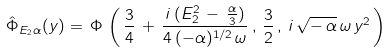Convert formula to latex. <formula><loc_0><loc_0><loc_500><loc_500>\hat { \Phi } _ { E _ { 2 } \alpha } ( y ) = \, \Phi \, \left ( \, \frac { 3 } { 4 } \, + \, \frac { i \, ( E _ { 2 } ^ { 2 } \, - \, \frac { \alpha } { 3 } ) } { 4 \, ( - \alpha ) ^ { 1 / 2 } \, \omega } \, , \, \frac { 3 } { 2 } \, , \, i \, \sqrt { - \, \alpha } \, \omega \, y ^ { 2 } \, \right ) \,</formula> 